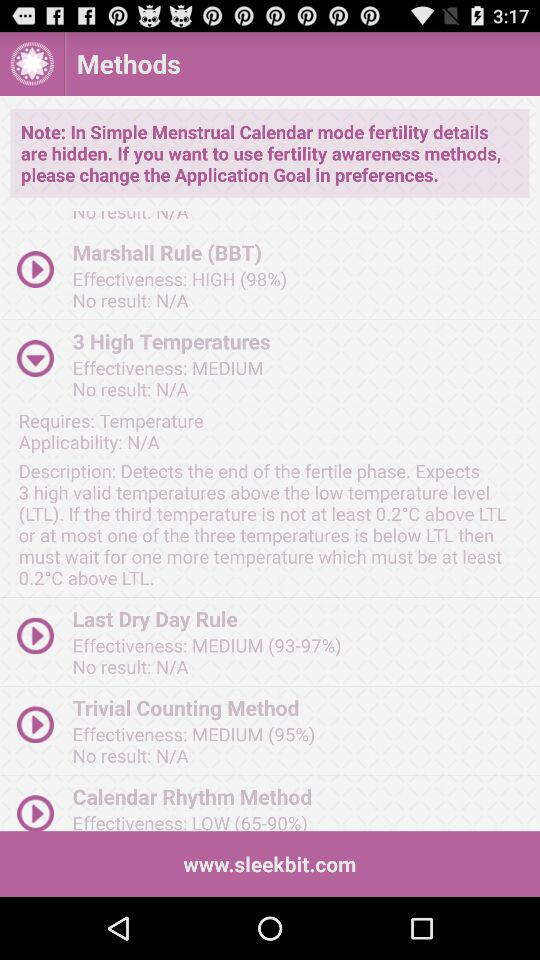How many methods have a medium effectiveness rating?
Answer the question using a single word or phrase. 3 